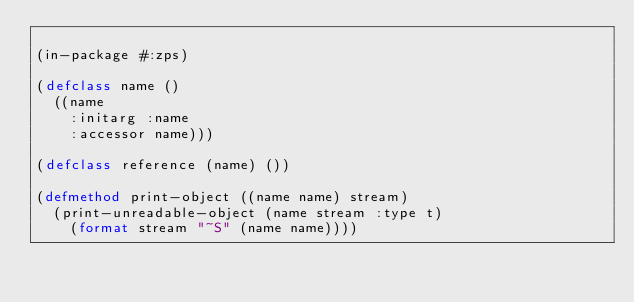<code> <loc_0><loc_0><loc_500><loc_500><_Lisp_>
(in-package #:zps)

(defclass name ()
  ((name
    :initarg :name
    :accessor name)))

(defclass reference (name) ())

(defmethod print-object ((name name) stream)
  (print-unreadable-object (name stream :type t)
    (format stream "~S" (name name))))



</code> 